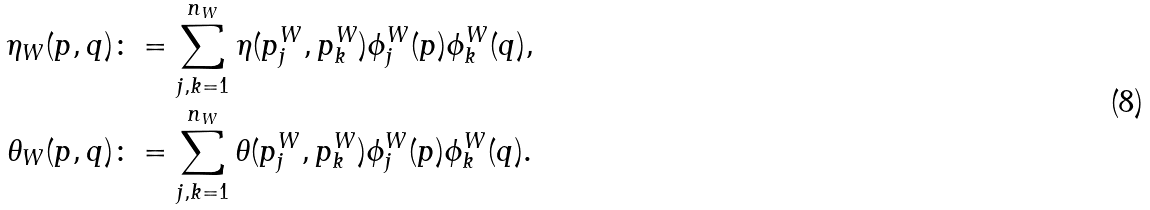Convert formula to latex. <formula><loc_0><loc_0><loc_500><loc_500>\eta _ { W } ( p , q ) & \colon = \sum _ { j , k = 1 } ^ { n _ { W } } \eta ( p ^ { W } _ { j } , p ^ { W } _ { k } ) \phi _ { j } ^ { W } ( p ) \phi _ { k } ^ { W } ( q ) , \\ \theta _ { W } ( p , q ) & \colon = \sum _ { j , k = 1 } ^ { n _ { W } } \theta ( p ^ { W } _ { j } , p ^ { W } _ { k } ) \phi _ { j } ^ { W } ( p ) \phi _ { k } ^ { W } ( q ) .</formula> 